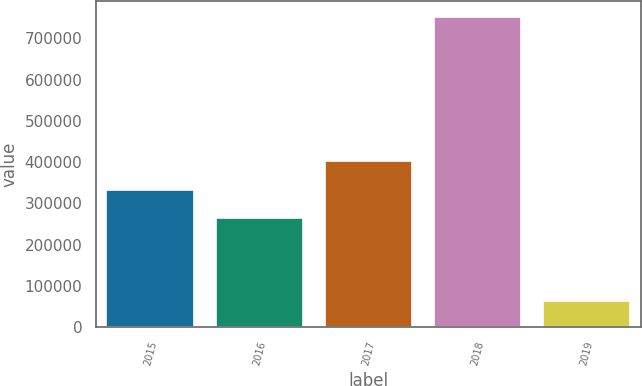Convert chart. <chart><loc_0><loc_0><loc_500><loc_500><bar_chart><fcel>2015<fcel>2016<fcel>2017<fcel>2018<fcel>2019<nl><fcel>332969<fcel>263975<fcel>401963<fcel>752732<fcel>62794<nl></chart> 